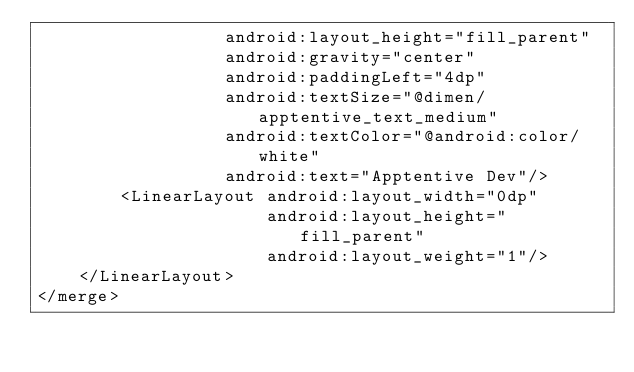Convert code to text. <code><loc_0><loc_0><loc_500><loc_500><_XML_>                  android:layout_height="fill_parent"
                  android:gravity="center"
                  android:paddingLeft="4dp"
                  android:textSize="@dimen/apptentive_text_medium"
                  android:textColor="@android:color/white"
                  android:text="Apptentive Dev"/>
        <LinearLayout android:layout_width="0dp"
                      android:layout_height="fill_parent"
                      android:layout_weight="1"/>
    </LinearLayout>
</merge></code> 